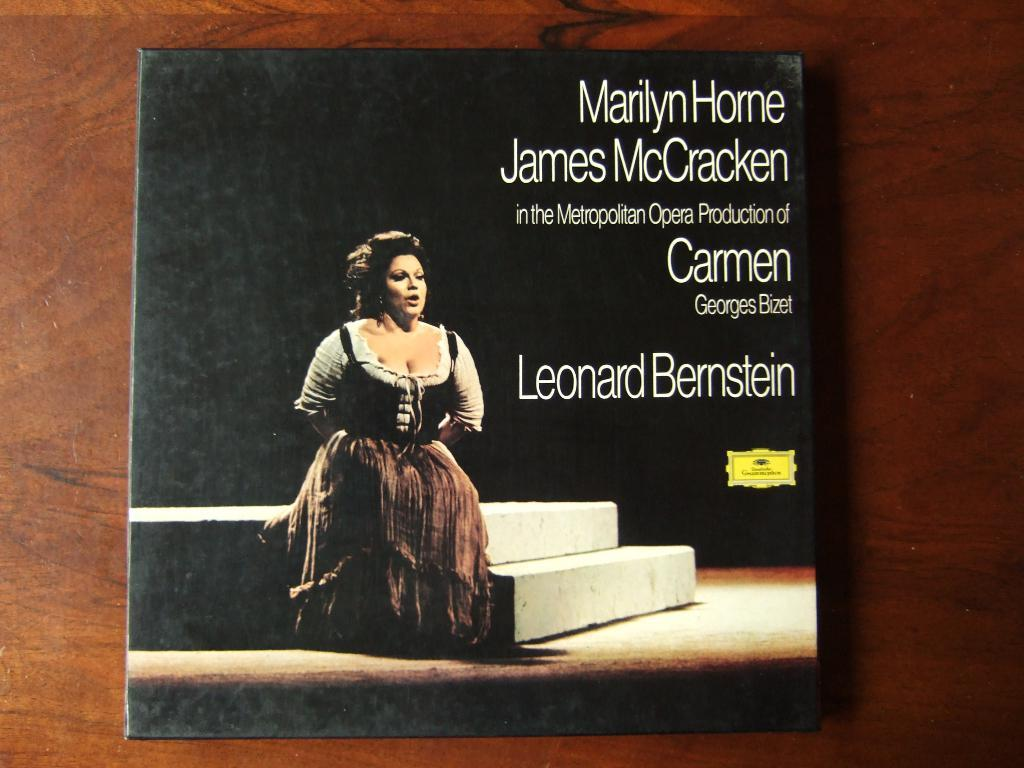<image>
Relay a brief, clear account of the picture shown. Marilyn Horne and James McCracken in the metropolitan opera production of Carmen. 